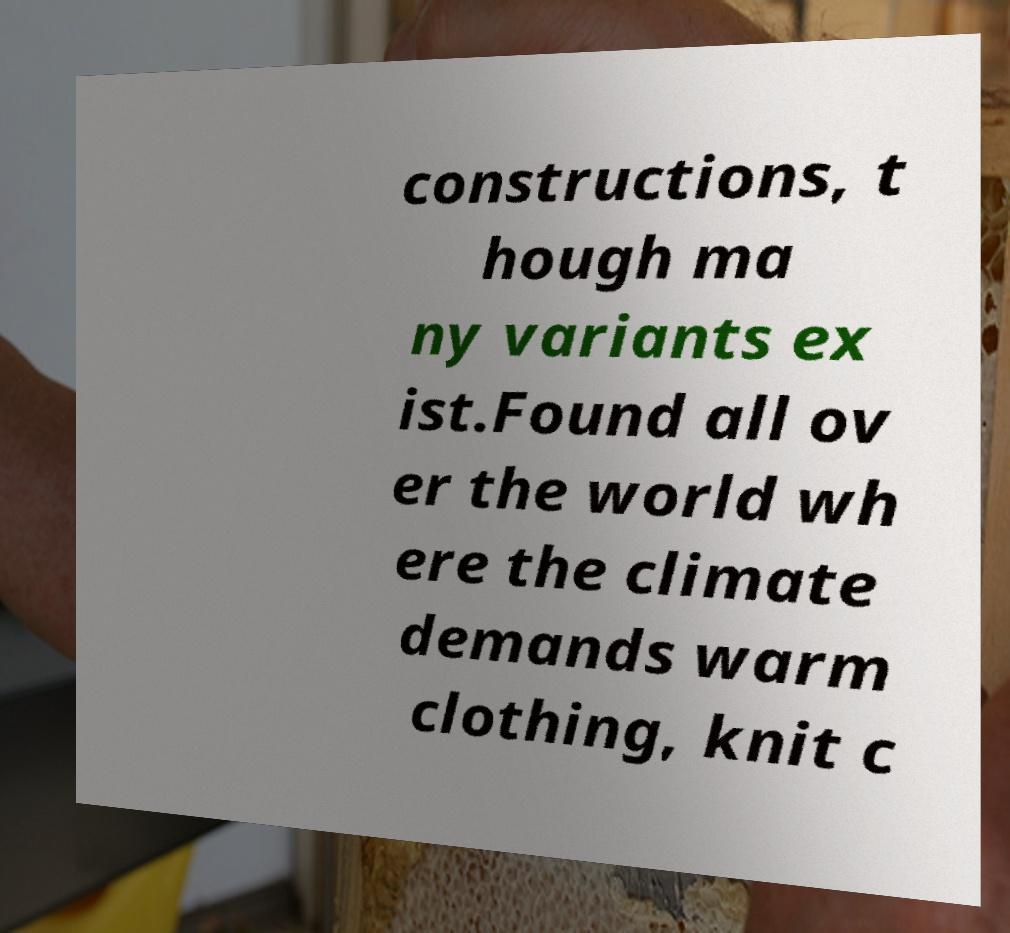Please identify and transcribe the text found in this image. constructions, t hough ma ny variants ex ist.Found all ov er the world wh ere the climate demands warm clothing, knit c 